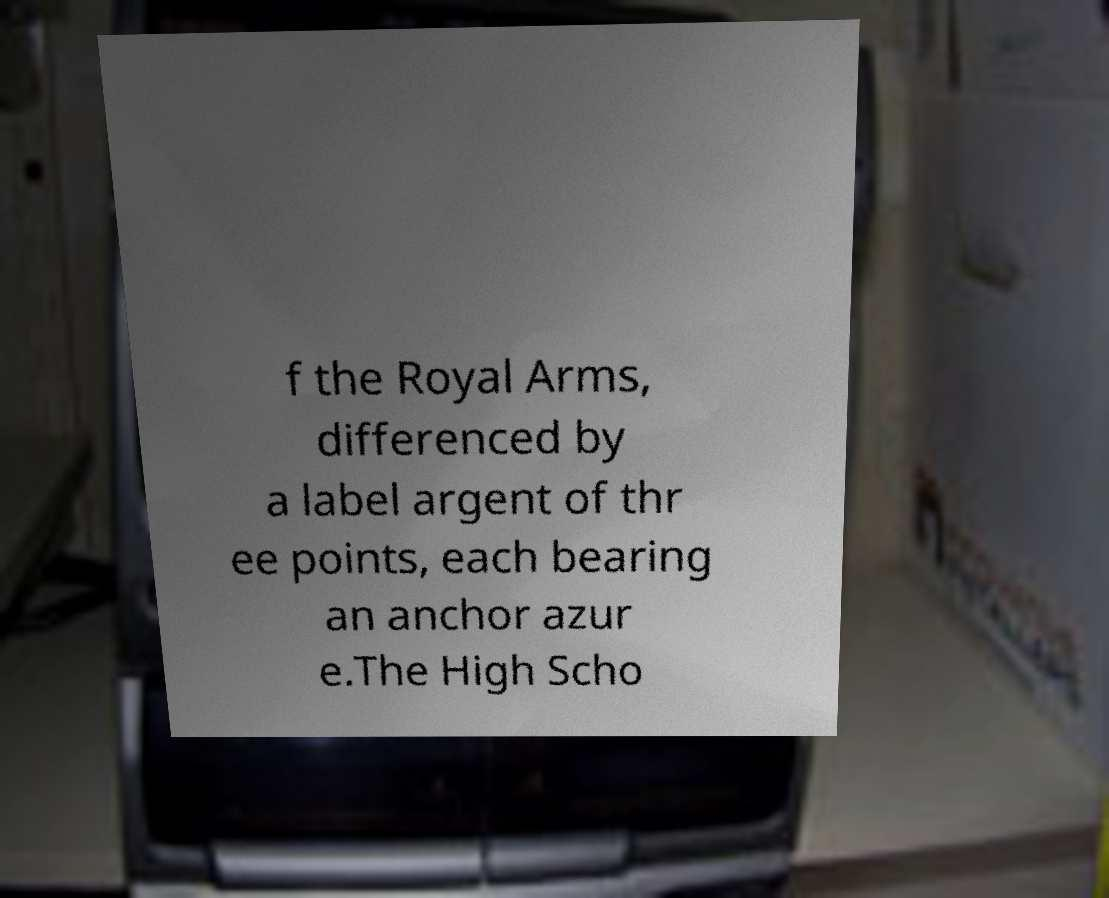There's text embedded in this image that I need extracted. Can you transcribe it verbatim? f the Royal Arms, differenced by a label argent of thr ee points, each bearing an anchor azur e.The High Scho 